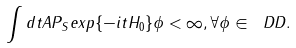<formula> <loc_0><loc_0><loc_500><loc_500>\int d t \| A P _ { S } e x p \{ - i t H _ { 0 } \} \phi \| < \infty , \forall \phi \in \ D D .</formula> 